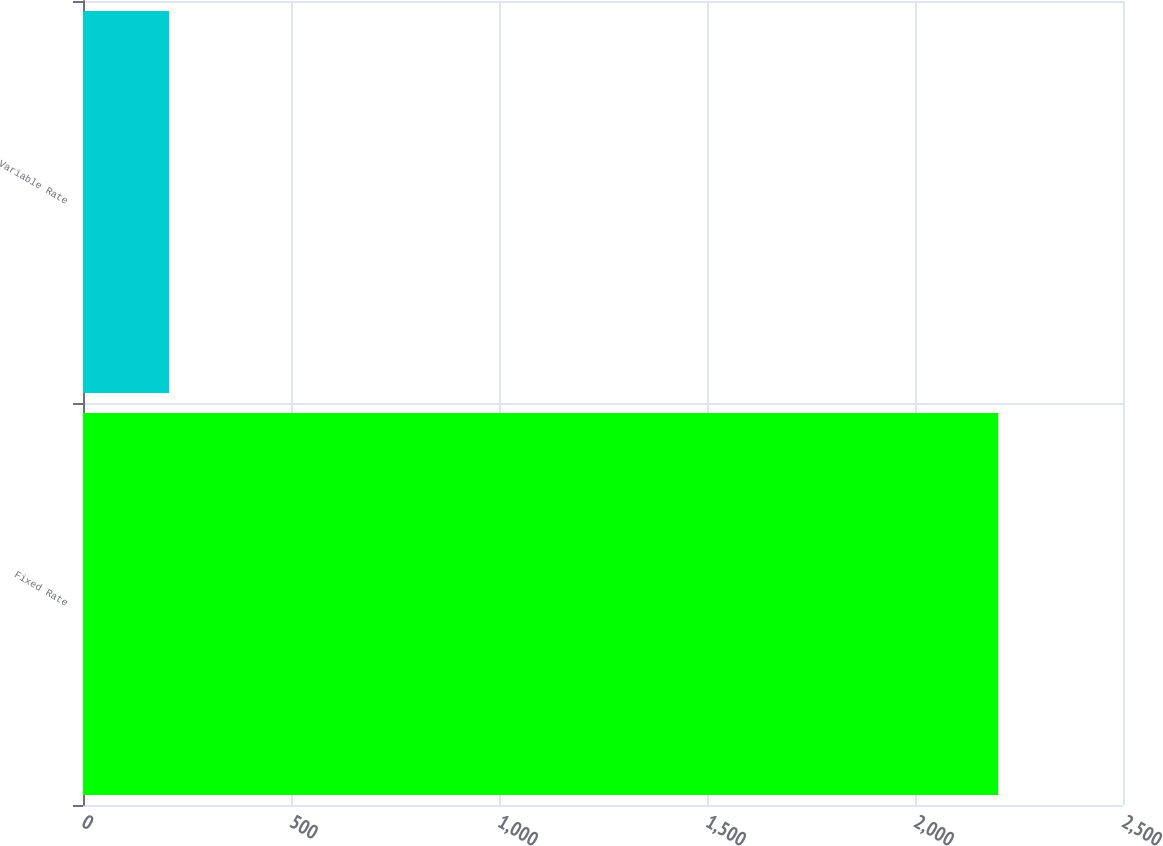Convert chart to OTSL. <chart><loc_0><loc_0><loc_500><loc_500><bar_chart><fcel>Fixed Rate<fcel>Variable Rate<nl><fcel>2200<fcel>207<nl></chart> 